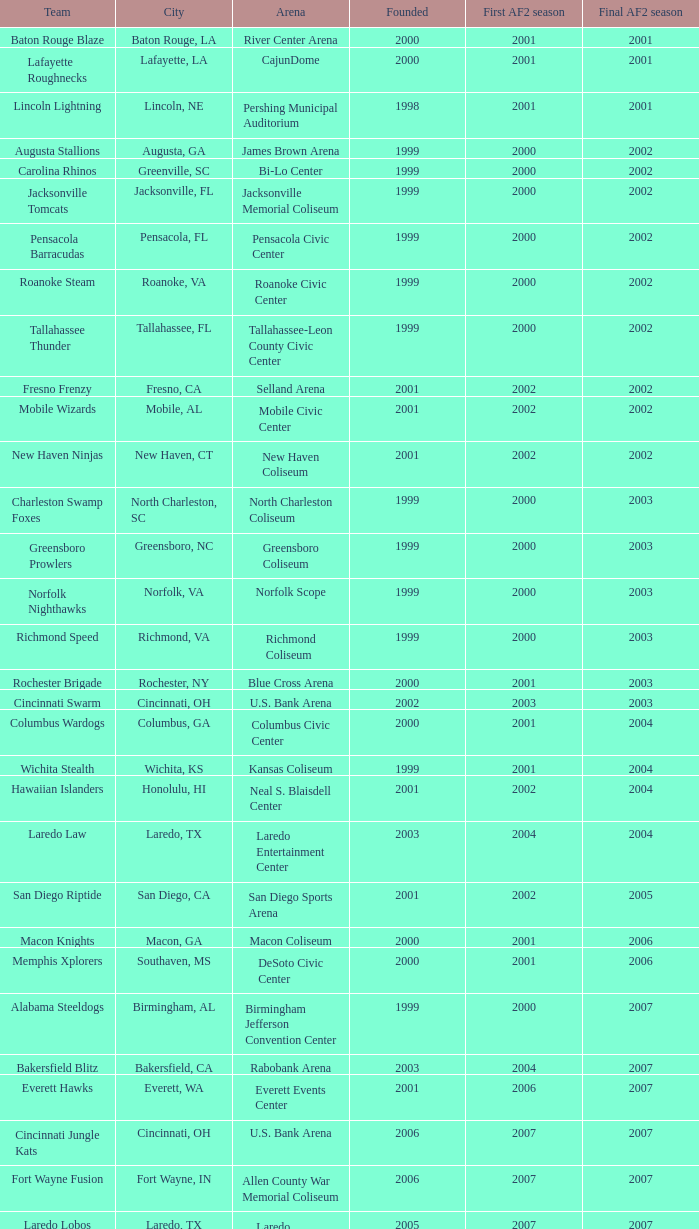How many founded years had a final af2 season prior to 2009 where the arena was the bi-lo center and the first af2 season was prior to 2000? 0.0. 